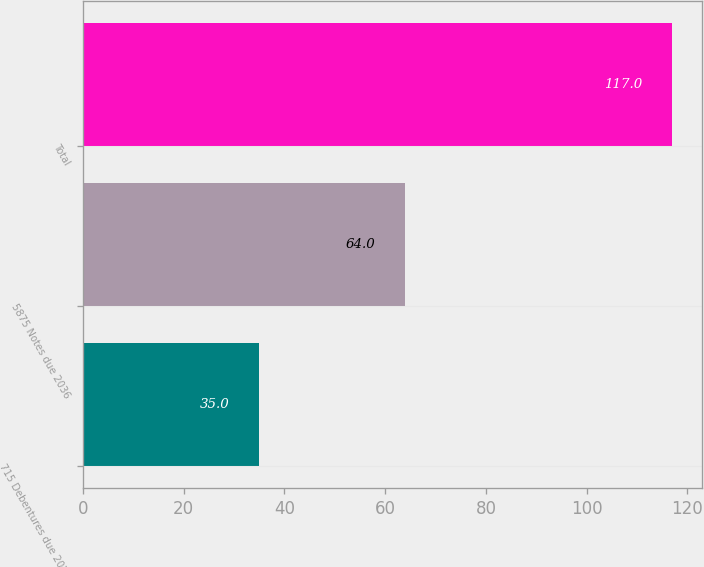Convert chart. <chart><loc_0><loc_0><loc_500><loc_500><bar_chart><fcel>715 Debentures due 2023<fcel>5875 Notes due 2036<fcel>Total<nl><fcel>35<fcel>64<fcel>117<nl></chart> 